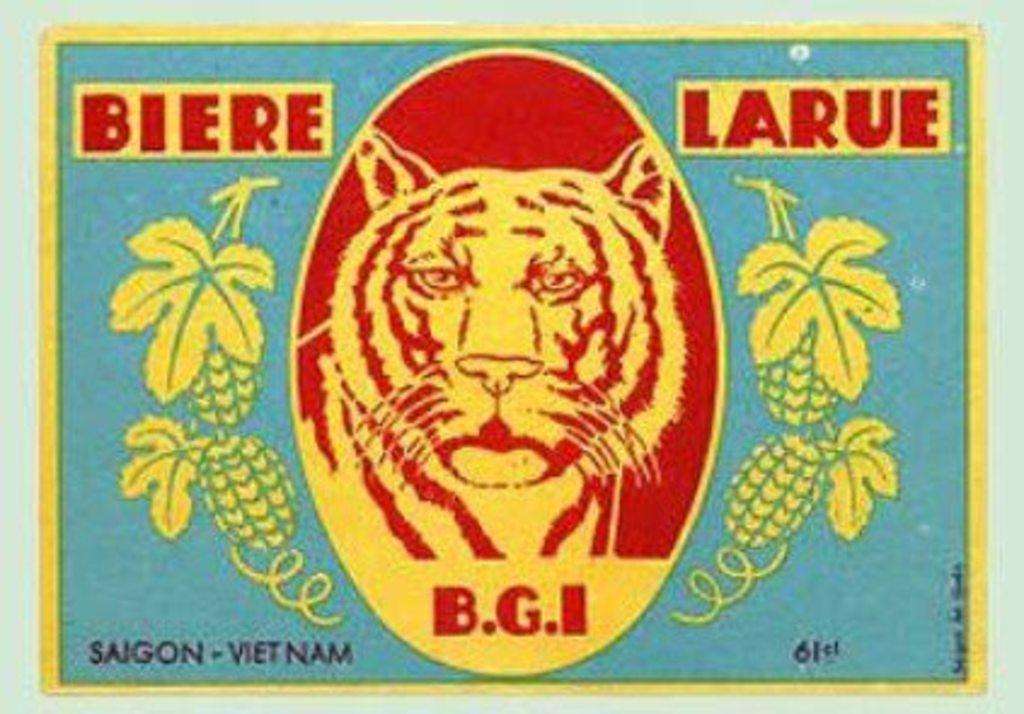What type of object is featured in the image? There is a poster in the image. What does the poster resemble? The poster resembles a stamp card. What animals or objects are depicted on the poster? There is a tiger and corn depicted on the poster. Are there any words or letters on the poster? Yes, there is text on the poster. How does the lettuce on the poster react to the tiger's presence? There is no lettuce depicted on the poster, only a tiger and corn. 